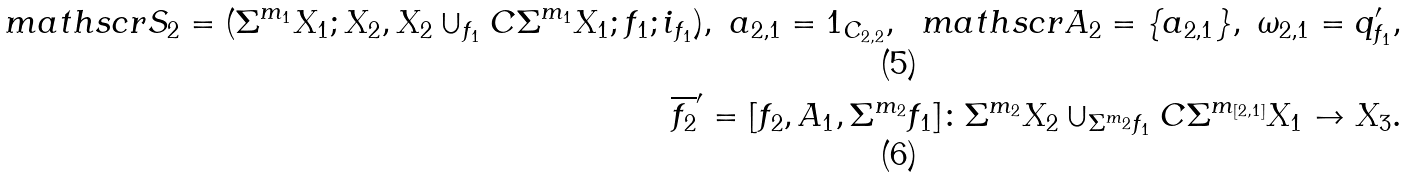Convert formula to latex. <formula><loc_0><loc_0><loc_500><loc_500>\ m a t h s c r { S } _ { 2 } = ( \Sigma ^ { m _ { 1 } } X _ { 1 } ; X _ { 2 } , X _ { 2 } \cup _ { f _ { 1 } } C \Sigma ^ { m _ { 1 } } X _ { 1 } ; f _ { 1 } ; i _ { f _ { 1 } } ) , \ a _ { 2 , 1 } = 1 _ { C _ { 2 , 2 } } , \ \ m a t h s c r { A } _ { 2 } = \{ a _ { 2 , 1 } \} , \ \omega _ { 2 , 1 } = q ^ { \prime } _ { f _ { 1 } } , \\ \overline { f _ { 2 } } ^ { \prime } = [ f _ { 2 } , A _ { 1 } , \Sigma ^ { m _ { 2 } } f _ { 1 } ] \colon \Sigma ^ { m _ { 2 } } X _ { 2 } \cup _ { \Sigma ^ { m _ { 2 } } f _ { 1 } } C \Sigma ^ { m _ { [ 2 , 1 ] } } X _ { 1 } \to X _ { 3 } .</formula> 